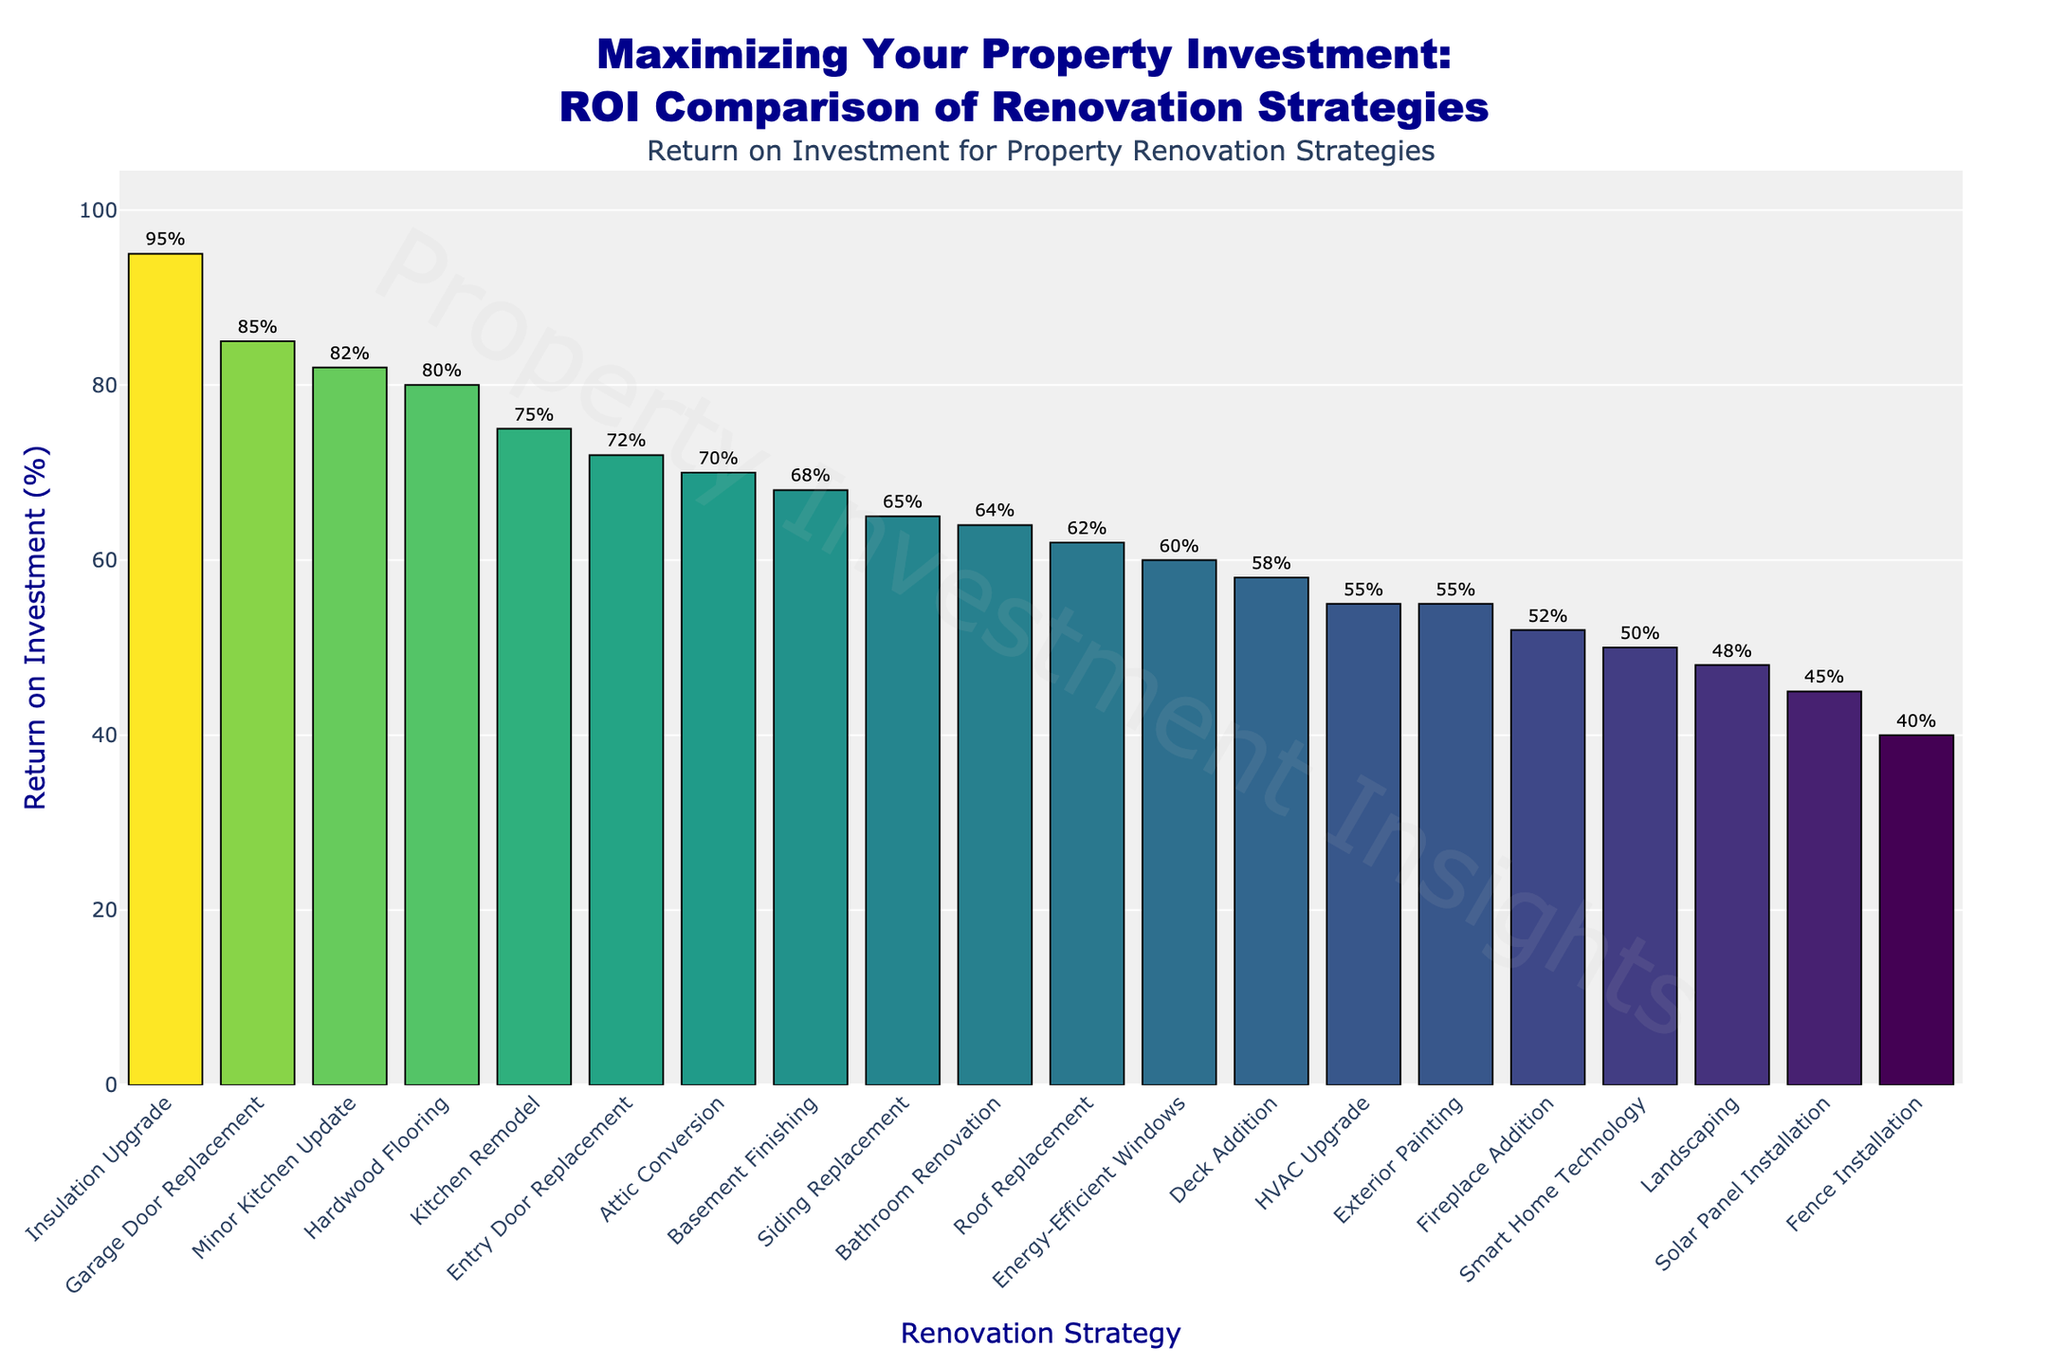Which renovation strategy has the highest ROI? To determine the strategy with the highest ROI, look at the tallest bar in the bar chart. The tallest bar represents the insulation upgrade strategy with an ROI of 95%.
Answer: Insulation Upgrade Which renovation strategy has a higher ROI: Deck Addition or Entry Door Replacement? Compare the heights of the bars for Deck Addition and Entry Door Replacement. Entry Door Replacement has an ROI higher than Deck Addition (72% vs. 58%).
Answer: Entry Door Replacement What is the average ROI of the top 3 renovation strategies? Identify the top 3 strategies by height: Insulation Upgrade (95%), Garage Door Replacement (85%), and Minor Kitchen Update (82%). Sum these values and divide by 3: (95 + 85 + 82) / 3.
Answer: 87.33 How much greater is the ROI of Hardwood Flooring compared to Solar Panel Installation? Compare the ROIs of Hardwood Flooring (80%) and Solar Panel Installation (45%). Subtract the ROI of Solar Panel Installation from Hardwood Flooring's ROI.
Answer: 35% Which strategy has the lowest ROI and what is its value? Find the shortest bar in the chart. The shortest bar represents Fence Installation with an ROI of 40%.
Answer: Fence Installation, 40% What is the combined ROI of Bathroom Renovation, Exterior Painting, and Energy-Efficient Windows? Add the ROI percentages of Bathroom Renovation (64%), Exterior Painting (55%), and Energy-Efficient Windows (60%): 64 + 55 + 60.
Answer: 179% How many renovation strategies have an ROI equal to or greater than 70%? Count the bars with heights corresponding to an ROI of 70% or more. They are Insulation Upgrade, Garage Door Replacement, Minor Kitchen Update, Hardwood Flooring, Kitchen Remodel, Entry Door Replacement, Attic Conversion, Basement Finishing. There are 8 of them.
Answer: 8 What is the difference in ROI between Kitchen Remodel and a Minor Kitchen Update? Subtract the ROI of Kitchen Remodel (75%) from the ROI of a Minor Kitchen Update (82%): 82 - 75.
Answer: 7% Which renovation strategies have an ROI between 55% and 65%? Identify the bars within the range of 55% to 65%. These strategies are Exterior Painting (55%), Energy-Efficient Windows (60%), Roof Replacement (62%), and Siding Replacement (65%).
Answer: Exterior Painting, Energy-Efficient Windows, Roof Replacement, Siding Replacement What is the median ROI value of all the strategies shown? List all ROI values in ascending order and find the middle value of the data set or the average of the middle two values if the count is even. Sorted values: 40, 45, 48, 50, 52, 55, 55, 58, 60, 62, 64, 65, 68, 70, 72, 75, 80, 82, 85, 95. The median, 10th and 11th values averaged: (62 + 64) / 2.
Answer: 63 